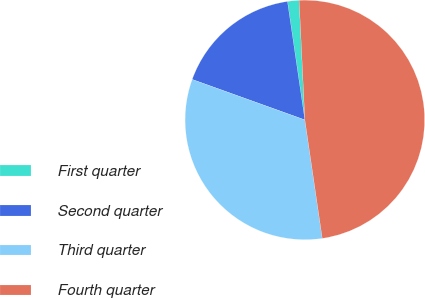Convert chart to OTSL. <chart><loc_0><loc_0><loc_500><loc_500><pie_chart><fcel>First quarter<fcel>Second quarter<fcel>Third quarter<fcel>Fourth quarter<nl><fcel>1.56%<fcel>17.19%<fcel>32.81%<fcel>48.44%<nl></chart> 